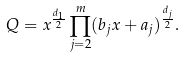<formula> <loc_0><loc_0><loc_500><loc_500>Q = x ^ { \frac { d _ { 1 } } { 2 } } \prod _ { j = 2 } ^ { m } ( b _ { j } x + a _ { j } ) ^ { \frac { d _ { j } } { 2 } } .</formula> 